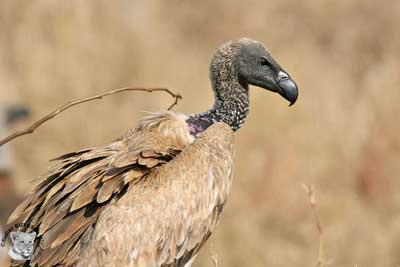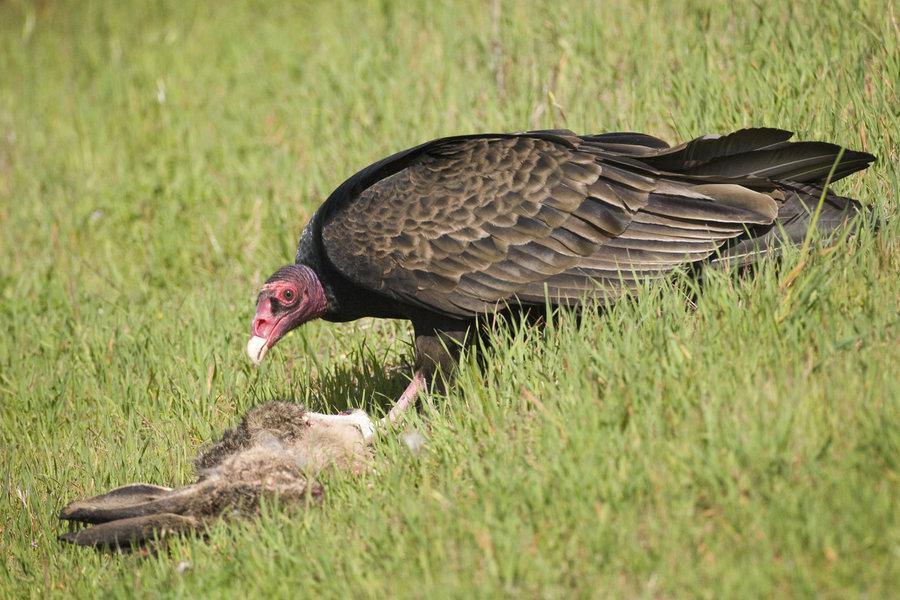The first image is the image on the left, the second image is the image on the right. For the images displayed, is the sentence "There is no more than one bird on the left image." factually correct? Answer yes or no. Yes. 